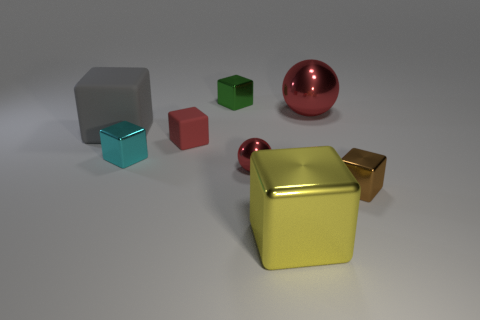Subtract all gray cubes. How many cubes are left? 5 Add 1 tiny brown metallic cylinders. How many objects exist? 9 Subtract all yellow blocks. How many blocks are left? 5 Subtract all spheres. How many objects are left? 6 Subtract all purple cylinders. How many gray blocks are left? 1 Subtract 4 cubes. How many cubes are left? 2 Subtract all brown spheres. Subtract all purple blocks. How many spheres are left? 2 Subtract all tiny brown things. Subtract all large yellow objects. How many objects are left? 6 Add 4 blocks. How many blocks are left? 10 Add 5 tiny green metal cubes. How many tiny green metal cubes exist? 6 